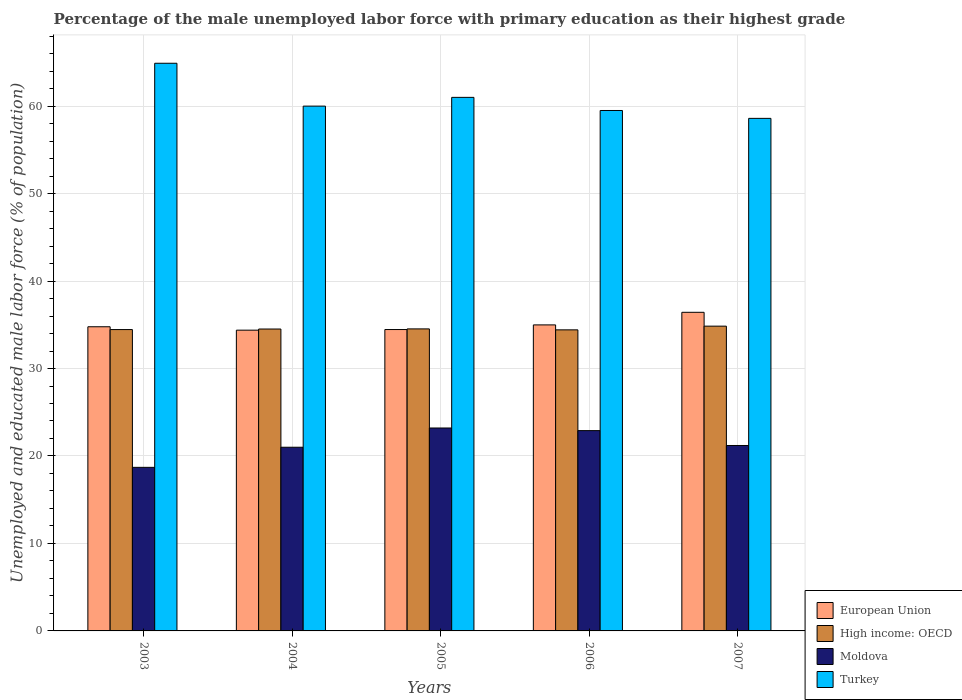How many different coloured bars are there?
Make the answer very short. 4. Are the number of bars on each tick of the X-axis equal?
Your response must be concise. Yes. How many bars are there on the 3rd tick from the right?
Your response must be concise. 4. What is the percentage of the unemployed male labor force with primary education in High income: OECD in 2004?
Offer a terse response. 34.51. Across all years, what is the maximum percentage of the unemployed male labor force with primary education in Turkey?
Your answer should be compact. 64.9. Across all years, what is the minimum percentage of the unemployed male labor force with primary education in European Union?
Provide a short and direct response. 34.39. In which year was the percentage of the unemployed male labor force with primary education in Moldova maximum?
Your response must be concise. 2005. In which year was the percentage of the unemployed male labor force with primary education in European Union minimum?
Your answer should be compact. 2004. What is the total percentage of the unemployed male labor force with primary education in Moldova in the graph?
Provide a succinct answer. 107. What is the difference between the percentage of the unemployed male labor force with primary education in Moldova in 2003 and that in 2006?
Make the answer very short. -4.2. What is the difference between the percentage of the unemployed male labor force with primary education in Moldova in 2003 and the percentage of the unemployed male labor force with primary education in High income: OECD in 2004?
Keep it short and to the point. -15.81. What is the average percentage of the unemployed male labor force with primary education in Moldova per year?
Keep it short and to the point. 21.4. In the year 2004, what is the difference between the percentage of the unemployed male labor force with primary education in European Union and percentage of the unemployed male labor force with primary education in High income: OECD?
Keep it short and to the point. -0.13. What is the ratio of the percentage of the unemployed male labor force with primary education in Turkey in 2003 to that in 2005?
Your answer should be compact. 1.06. Is the percentage of the unemployed male labor force with primary education in European Union in 2005 less than that in 2007?
Ensure brevity in your answer.  Yes. What is the difference between the highest and the second highest percentage of the unemployed male labor force with primary education in High income: OECD?
Ensure brevity in your answer.  0.31. What does the 1st bar from the left in 2004 represents?
Provide a succinct answer. European Union. What does the 4th bar from the right in 2004 represents?
Keep it short and to the point. European Union. How many bars are there?
Provide a succinct answer. 20. Are the values on the major ticks of Y-axis written in scientific E-notation?
Ensure brevity in your answer.  No. Does the graph contain grids?
Provide a succinct answer. Yes. How are the legend labels stacked?
Keep it short and to the point. Vertical. What is the title of the graph?
Ensure brevity in your answer.  Percentage of the male unemployed labor force with primary education as their highest grade. What is the label or title of the X-axis?
Your answer should be very brief. Years. What is the label or title of the Y-axis?
Your response must be concise. Unemployed and educated male labor force (% of population). What is the Unemployed and educated male labor force (% of population) of European Union in 2003?
Your response must be concise. 34.77. What is the Unemployed and educated male labor force (% of population) in High income: OECD in 2003?
Your response must be concise. 34.45. What is the Unemployed and educated male labor force (% of population) of Moldova in 2003?
Offer a terse response. 18.7. What is the Unemployed and educated male labor force (% of population) in Turkey in 2003?
Provide a succinct answer. 64.9. What is the Unemployed and educated male labor force (% of population) of European Union in 2004?
Make the answer very short. 34.39. What is the Unemployed and educated male labor force (% of population) of High income: OECD in 2004?
Give a very brief answer. 34.51. What is the Unemployed and educated male labor force (% of population) in Moldova in 2004?
Keep it short and to the point. 21. What is the Unemployed and educated male labor force (% of population) in Turkey in 2004?
Keep it short and to the point. 60. What is the Unemployed and educated male labor force (% of population) in European Union in 2005?
Your answer should be compact. 34.46. What is the Unemployed and educated male labor force (% of population) of High income: OECD in 2005?
Offer a terse response. 34.53. What is the Unemployed and educated male labor force (% of population) in Moldova in 2005?
Make the answer very short. 23.2. What is the Unemployed and educated male labor force (% of population) in European Union in 2006?
Provide a succinct answer. 34.99. What is the Unemployed and educated male labor force (% of population) of High income: OECD in 2006?
Give a very brief answer. 34.42. What is the Unemployed and educated male labor force (% of population) of Moldova in 2006?
Your answer should be compact. 22.9. What is the Unemployed and educated male labor force (% of population) of Turkey in 2006?
Make the answer very short. 59.5. What is the Unemployed and educated male labor force (% of population) of European Union in 2007?
Provide a short and direct response. 36.43. What is the Unemployed and educated male labor force (% of population) of High income: OECD in 2007?
Keep it short and to the point. 34.84. What is the Unemployed and educated male labor force (% of population) in Moldova in 2007?
Offer a very short reply. 21.2. What is the Unemployed and educated male labor force (% of population) in Turkey in 2007?
Make the answer very short. 58.6. Across all years, what is the maximum Unemployed and educated male labor force (% of population) in European Union?
Keep it short and to the point. 36.43. Across all years, what is the maximum Unemployed and educated male labor force (% of population) in High income: OECD?
Offer a terse response. 34.84. Across all years, what is the maximum Unemployed and educated male labor force (% of population) in Moldova?
Provide a succinct answer. 23.2. Across all years, what is the maximum Unemployed and educated male labor force (% of population) in Turkey?
Keep it short and to the point. 64.9. Across all years, what is the minimum Unemployed and educated male labor force (% of population) in European Union?
Give a very brief answer. 34.39. Across all years, what is the minimum Unemployed and educated male labor force (% of population) of High income: OECD?
Offer a terse response. 34.42. Across all years, what is the minimum Unemployed and educated male labor force (% of population) of Moldova?
Give a very brief answer. 18.7. Across all years, what is the minimum Unemployed and educated male labor force (% of population) in Turkey?
Give a very brief answer. 58.6. What is the total Unemployed and educated male labor force (% of population) of European Union in the graph?
Give a very brief answer. 175.03. What is the total Unemployed and educated male labor force (% of population) in High income: OECD in the graph?
Give a very brief answer. 172.76. What is the total Unemployed and educated male labor force (% of population) of Moldova in the graph?
Give a very brief answer. 107. What is the total Unemployed and educated male labor force (% of population) of Turkey in the graph?
Make the answer very short. 304. What is the difference between the Unemployed and educated male labor force (% of population) of European Union in 2003 and that in 2004?
Provide a succinct answer. 0.39. What is the difference between the Unemployed and educated male labor force (% of population) of High income: OECD in 2003 and that in 2004?
Your answer should be compact. -0.06. What is the difference between the Unemployed and educated male labor force (% of population) of Moldova in 2003 and that in 2004?
Make the answer very short. -2.3. What is the difference between the Unemployed and educated male labor force (% of population) of Turkey in 2003 and that in 2004?
Your answer should be very brief. 4.9. What is the difference between the Unemployed and educated male labor force (% of population) in European Union in 2003 and that in 2005?
Your answer should be compact. 0.32. What is the difference between the Unemployed and educated male labor force (% of population) in High income: OECD in 2003 and that in 2005?
Keep it short and to the point. -0.08. What is the difference between the Unemployed and educated male labor force (% of population) in Turkey in 2003 and that in 2005?
Make the answer very short. 3.9. What is the difference between the Unemployed and educated male labor force (% of population) of European Union in 2003 and that in 2006?
Keep it short and to the point. -0.21. What is the difference between the Unemployed and educated male labor force (% of population) in High income: OECD in 2003 and that in 2006?
Give a very brief answer. 0.03. What is the difference between the Unemployed and educated male labor force (% of population) in European Union in 2003 and that in 2007?
Make the answer very short. -1.65. What is the difference between the Unemployed and educated male labor force (% of population) in High income: OECD in 2003 and that in 2007?
Provide a short and direct response. -0.39. What is the difference between the Unemployed and educated male labor force (% of population) of European Union in 2004 and that in 2005?
Give a very brief answer. -0.07. What is the difference between the Unemployed and educated male labor force (% of population) in High income: OECD in 2004 and that in 2005?
Provide a short and direct response. -0.02. What is the difference between the Unemployed and educated male labor force (% of population) in European Union in 2004 and that in 2006?
Make the answer very short. -0.6. What is the difference between the Unemployed and educated male labor force (% of population) of High income: OECD in 2004 and that in 2006?
Offer a terse response. 0.09. What is the difference between the Unemployed and educated male labor force (% of population) of Moldova in 2004 and that in 2006?
Make the answer very short. -1.9. What is the difference between the Unemployed and educated male labor force (% of population) in Turkey in 2004 and that in 2006?
Offer a terse response. 0.5. What is the difference between the Unemployed and educated male labor force (% of population) of European Union in 2004 and that in 2007?
Your answer should be compact. -2.04. What is the difference between the Unemployed and educated male labor force (% of population) in High income: OECD in 2004 and that in 2007?
Ensure brevity in your answer.  -0.33. What is the difference between the Unemployed and educated male labor force (% of population) in Turkey in 2004 and that in 2007?
Give a very brief answer. 1.4. What is the difference between the Unemployed and educated male labor force (% of population) of European Union in 2005 and that in 2006?
Ensure brevity in your answer.  -0.53. What is the difference between the Unemployed and educated male labor force (% of population) of High income: OECD in 2005 and that in 2006?
Give a very brief answer. 0.11. What is the difference between the Unemployed and educated male labor force (% of population) in Moldova in 2005 and that in 2006?
Make the answer very short. 0.3. What is the difference between the Unemployed and educated male labor force (% of population) of European Union in 2005 and that in 2007?
Give a very brief answer. -1.97. What is the difference between the Unemployed and educated male labor force (% of population) in High income: OECD in 2005 and that in 2007?
Give a very brief answer. -0.31. What is the difference between the Unemployed and educated male labor force (% of population) in Moldova in 2005 and that in 2007?
Offer a very short reply. 2. What is the difference between the Unemployed and educated male labor force (% of population) of Turkey in 2005 and that in 2007?
Your answer should be very brief. 2.4. What is the difference between the Unemployed and educated male labor force (% of population) of European Union in 2006 and that in 2007?
Offer a very short reply. -1.44. What is the difference between the Unemployed and educated male labor force (% of population) of High income: OECD in 2006 and that in 2007?
Provide a short and direct response. -0.42. What is the difference between the Unemployed and educated male labor force (% of population) in European Union in 2003 and the Unemployed and educated male labor force (% of population) in High income: OECD in 2004?
Ensure brevity in your answer.  0.26. What is the difference between the Unemployed and educated male labor force (% of population) of European Union in 2003 and the Unemployed and educated male labor force (% of population) of Moldova in 2004?
Your answer should be compact. 13.77. What is the difference between the Unemployed and educated male labor force (% of population) of European Union in 2003 and the Unemployed and educated male labor force (% of population) of Turkey in 2004?
Offer a very short reply. -25.23. What is the difference between the Unemployed and educated male labor force (% of population) of High income: OECD in 2003 and the Unemployed and educated male labor force (% of population) of Moldova in 2004?
Ensure brevity in your answer.  13.45. What is the difference between the Unemployed and educated male labor force (% of population) in High income: OECD in 2003 and the Unemployed and educated male labor force (% of population) in Turkey in 2004?
Offer a terse response. -25.55. What is the difference between the Unemployed and educated male labor force (% of population) of Moldova in 2003 and the Unemployed and educated male labor force (% of population) of Turkey in 2004?
Your response must be concise. -41.3. What is the difference between the Unemployed and educated male labor force (% of population) in European Union in 2003 and the Unemployed and educated male labor force (% of population) in High income: OECD in 2005?
Your answer should be compact. 0.24. What is the difference between the Unemployed and educated male labor force (% of population) of European Union in 2003 and the Unemployed and educated male labor force (% of population) of Moldova in 2005?
Your answer should be compact. 11.57. What is the difference between the Unemployed and educated male labor force (% of population) in European Union in 2003 and the Unemployed and educated male labor force (% of population) in Turkey in 2005?
Provide a short and direct response. -26.23. What is the difference between the Unemployed and educated male labor force (% of population) in High income: OECD in 2003 and the Unemployed and educated male labor force (% of population) in Moldova in 2005?
Provide a short and direct response. 11.25. What is the difference between the Unemployed and educated male labor force (% of population) in High income: OECD in 2003 and the Unemployed and educated male labor force (% of population) in Turkey in 2005?
Your answer should be very brief. -26.55. What is the difference between the Unemployed and educated male labor force (% of population) of Moldova in 2003 and the Unemployed and educated male labor force (% of population) of Turkey in 2005?
Offer a very short reply. -42.3. What is the difference between the Unemployed and educated male labor force (% of population) of European Union in 2003 and the Unemployed and educated male labor force (% of population) of High income: OECD in 2006?
Give a very brief answer. 0.35. What is the difference between the Unemployed and educated male labor force (% of population) of European Union in 2003 and the Unemployed and educated male labor force (% of population) of Moldova in 2006?
Ensure brevity in your answer.  11.87. What is the difference between the Unemployed and educated male labor force (% of population) of European Union in 2003 and the Unemployed and educated male labor force (% of population) of Turkey in 2006?
Make the answer very short. -24.73. What is the difference between the Unemployed and educated male labor force (% of population) in High income: OECD in 2003 and the Unemployed and educated male labor force (% of population) in Moldova in 2006?
Keep it short and to the point. 11.55. What is the difference between the Unemployed and educated male labor force (% of population) of High income: OECD in 2003 and the Unemployed and educated male labor force (% of population) of Turkey in 2006?
Keep it short and to the point. -25.05. What is the difference between the Unemployed and educated male labor force (% of population) in Moldova in 2003 and the Unemployed and educated male labor force (% of population) in Turkey in 2006?
Your response must be concise. -40.8. What is the difference between the Unemployed and educated male labor force (% of population) in European Union in 2003 and the Unemployed and educated male labor force (% of population) in High income: OECD in 2007?
Keep it short and to the point. -0.07. What is the difference between the Unemployed and educated male labor force (% of population) in European Union in 2003 and the Unemployed and educated male labor force (% of population) in Moldova in 2007?
Make the answer very short. 13.57. What is the difference between the Unemployed and educated male labor force (% of population) in European Union in 2003 and the Unemployed and educated male labor force (% of population) in Turkey in 2007?
Provide a short and direct response. -23.83. What is the difference between the Unemployed and educated male labor force (% of population) in High income: OECD in 2003 and the Unemployed and educated male labor force (% of population) in Moldova in 2007?
Ensure brevity in your answer.  13.25. What is the difference between the Unemployed and educated male labor force (% of population) of High income: OECD in 2003 and the Unemployed and educated male labor force (% of population) of Turkey in 2007?
Offer a very short reply. -24.15. What is the difference between the Unemployed and educated male labor force (% of population) of Moldova in 2003 and the Unemployed and educated male labor force (% of population) of Turkey in 2007?
Offer a terse response. -39.9. What is the difference between the Unemployed and educated male labor force (% of population) in European Union in 2004 and the Unemployed and educated male labor force (% of population) in High income: OECD in 2005?
Keep it short and to the point. -0.14. What is the difference between the Unemployed and educated male labor force (% of population) of European Union in 2004 and the Unemployed and educated male labor force (% of population) of Moldova in 2005?
Your answer should be very brief. 11.19. What is the difference between the Unemployed and educated male labor force (% of population) in European Union in 2004 and the Unemployed and educated male labor force (% of population) in Turkey in 2005?
Provide a short and direct response. -26.61. What is the difference between the Unemployed and educated male labor force (% of population) in High income: OECD in 2004 and the Unemployed and educated male labor force (% of population) in Moldova in 2005?
Offer a very short reply. 11.31. What is the difference between the Unemployed and educated male labor force (% of population) of High income: OECD in 2004 and the Unemployed and educated male labor force (% of population) of Turkey in 2005?
Your answer should be very brief. -26.49. What is the difference between the Unemployed and educated male labor force (% of population) in Moldova in 2004 and the Unemployed and educated male labor force (% of population) in Turkey in 2005?
Ensure brevity in your answer.  -40. What is the difference between the Unemployed and educated male labor force (% of population) in European Union in 2004 and the Unemployed and educated male labor force (% of population) in High income: OECD in 2006?
Your response must be concise. -0.03. What is the difference between the Unemployed and educated male labor force (% of population) in European Union in 2004 and the Unemployed and educated male labor force (% of population) in Moldova in 2006?
Give a very brief answer. 11.49. What is the difference between the Unemployed and educated male labor force (% of population) in European Union in 2004 and the Unemployed and educated male labor force (% of population) in Turkey in 2006?
Ensure brevity in your answer.  -25.11. What is the difference between the Unemployed and educated male labor force (% of population) of High income: OECD in 2004 and the Unemployed and educated male labor force (% of population) of Moldova in 2006?
Your answer should be very brief. 11.61. What is the difference between the Unemployed and educated male labor force (% of population) of High income: OECD in 2004 and the Unemployed and educated male labor force (% of population) of Turkey in 2006?
Offer a very short reply. -24.99. What is the difference between the Unemployed and educated male labor force (% of population) in Moldova in 2004 and the Unemployed and educated male labor force (% of population) in Turkey in 2006?
Provide a short and direct response. -38.5. What is the difference between the Unemployed and educated male labor force (% of population) in European Union in 2004 and the Unemployed and educated male labor force (% of population) in High income: OECD in 2007?
Your response must be concise. -0.46. What is the difference between the Unemployed and educated male labor force (% of population) in European Union in 2004 and the Unemployed and educated male labor force (% of population) in Moldova in 2007?
Give a very brief answer. 13.19. What is the difference between the Unemployed and educated male labor force (% of population) in European Union in 2004 and the Unemployed and educated male labor force (% of population) in Turkey in 2007?
Offer a very short reply. -24.21. What is the difference between the Unemployed and educated male labor force (% of population) in High income: OECD in 2004 and the Unemployed and educated male labor force (% of population) in Moldova in 2007?
Your answer should be compact. 13.31. What is the difference between the Unemployed and educated male labor force (% of population) in High income: OECD in 2004 and the Unemployed and educated male labor force (% of population) in Turkey in 2007?
Your response must be concise. -24.09. What is the difference between the Unemployed and educated male labor force (% of population) in Moldova in 2004 and the Unemployed and educated male labor force (% of population) in Turkey in 2007?
Your answer should be compact. -37.6. What is the difference between the Unemployed and educated male labor force (% of population) in European Union in 2005 and the Unemployed and educated male labor force (% of population) in High income: OECD in 2006?
Make the answer very short. 0.04. What is the difference between the Unemployed and educated male labor force (% of population) of European Union in 2005 and the Unemployed and educated male labor force (% of population) of Moldova in 2006?
Make the answer very short. 11.56. What is the difference between the Unemployed and educated male labor force (% of population) of European Union in 2005 and the Unemployed and educated male labor force (% of population) of Turkey in 2006?
Your answer should be very brief. -25.04. What is the difference between the Unemployed and educated male labor force (% of population) in High income: OECD in 2005 and the Unemployed and educated male labor force (% of population) in Moldova in 2006?
Give a very brief answer. 11.63. What is the difference between the Unemployed and educated male labor force (% of population) of High income: OECD in 2005 and the Unemployed and educated male labor force (% of population) of Turkey in 2006?
Keep it short and to the point. -24.97. What is the difference between the Unemployed and educated male labor force (% of population) of Moldova in 2005 and the Unemployed and educated male labor force (% of population) of Turkey in 2006?
Give a very brief answer. -36.3. What is the difference between the Unemployed and educated male labor force (% of population) of European Union in 2005 and the Unemployed and educated male labor force (% of population) of High income: OECD in 2007?
Your response must be concise. -0.39. What is the difference between the Unemployed and educated male labor force (% of population) of European Union in 2005 and the Unemployed and educated male labor force (% of population) of Moldova in 2007?
Give a very brief answer. 13.26. What is the difference between the Unemployed and educated male labor force (% of population) of European Union in 2005 and the Unemployed and educated male labor force (% of population) of Turkey in 2007?
Offer a very short reply. -24.14. What is the difference between the Unemployed and educated male labor force (% of population) of High income: OECD in 2005 and the Unemployed and educated male labor force (% of population) of Moldova in 2007?
Your answer should be compact. 13.33. What is the difference between the Unemployed and educated male labor force (% of population) of High income: OECD in 2005 and the Unemployed and educated male labor force (% of population) of Turkey in 2007?
Give a very brief answer. -24.07. What is the difference between the Unemployed and educated male labor force (% of population) in Moldova in 2005 and the Unemployed and educated male labor force (% of population) in Turkey in 2007?
Make the answer very short. -35.4. What is the difference between the Unemployed and educated male labor force (% of population) of European Union in 2006 and the Unemployed and educated male labor force (% of population) of High income: OECD in 2007?
Make the answer very short. 0.14. What is the difference between the Unemployed and educated male labor force (% of population) of European Union in 2006 and the Unemployed and educated male labor force (% of population) of Moldova in 2007?
Offer a terse response. 13.79. What is the difference between the Unemployed and educated male labor force (% of population) in European Union in 2006 and the Unemployed and educated male labor force (% of population) in Turkey in 2007?
Offer a very short reply. -23.61. What is the difference between the Unemployed and educated male labor force (% of population) of High income: OECD in 2006 and the Unemployed and educated male labor force (% of population) of Moldova in 2007?
Offer a very short reply. 13.22. What is the difference between the Unemployed and educated male labor force (% of population) of High income: OECD in 2006 and the Unemployed and educated male labor force (% of population) of Turkey in 2007?
Keep it short and to the point. -24.18. What is the difference between the Unemployed and educated male labor force (% of population) of Moldova in 2006 and the Unemployed and educated male labor force (% of population) of Turkey in 2007?
Your response must be concise. -35.7. What is the average Unemployed and educated male labor force (% of population) of European Union per year?
Give a very brief answer. 35.01. What is the average Unemployed and educated male labor force (% of population) in High income: OECD per year?
Offer a very short reply. 34.55. What is the average Unemployed and educated male labor force (% of population) in Moldova per year?
Ensure brevity in your answer.  21.4. What is the average Unemployed and educated male labor force (% of population) in Turkey per year?
Your answer should be very brief. 60.8. In the year 2003, what is the difference between the Unemployed and educated male labor force (% of population) in European Union and Unemployed and educated male labor force (% of population) in High income: OECD?
Give a very brief answer. 0.32. In the year 2003, what is the difference between the Unemployed and educated male labor force (% of population) of European Union and Unemployed and educated male labor force (% of population) of Moldova?
Your answer should be very brief. 16.07. In the year 2003, what is the difference between the Unemployed and educated male labor force (% of population) in European Union and Unemployed and educated male labor force (% of population) in Turkey?
Your answer should be very brief. -30.13. In the year 2003, what is the difference between the Unemployed and educated male labor force (% of population) in High income: OECD and Unemployed and educated male labor force (% of population) in Moldova?
Keep it short and to the point. 15.75. In the year 2003, what is the difference between the Unemployed and educated male labor force (% of population) in High income: OECD and Unemployed and educated male labor force (% of population) in Turkey?
Your response must be concise. -30.45. In the year 2003, what is the difference between the Unemployed and educated male labor force (% of population) of Moldova and Unemployed and educated male labor force (% of population) of Turkey?
Give a very brief answer. -46.2. In the year 2004, what is the difference between the Unemployed and educated male labor force (% of population) of European Union and Unemployed and educated male labor force (% of population) of High income: OECD?
Ensure brevity in your answer.  -0.13. In the year 2004, what is the difference between the Unemployed and educated male labor force (% of population) in European Union and Unemployed and educated male labor force (% of population) in Moldova?
Your answer should be very brief. 13.39. In the year 2004, what is the difference between the Unemployed and educated male labor force (% of population) in European Union and Unemployed and educated male labor force (% of population) in Turkey?
Make the answer very short. -25.61. In the year 2004, what is the difference between the Unemployed and educated male labor force (% of population) of High income: OECD and Unemployed and educated male labor force (% of population) of Moldova?
Give a very brief answer. 13.51. In the year 2004, what is the difference between the Unemployed and educated male labor force (% of population) of High income: OECD and Unemployed and educated male labor force (% of population) of Turkey?
Provide a short and direct response. -25.49. In the year 2004, what is the difference between the Unemployed and educated male labor force (% of population) of Moldova and Unemployed and educated male labor force (% of population) of Turkey?
Make the answer very short. -39. In the year 2005, what is the difference between the Unemployed and educated male labor force (% of population) of European Union and Unemployed and educated male labor force (% of population) of High income: OECD?
Offer a very short reply. -0.07. In the year 2005, what is the difference between the Unemployed and educated male labor force (% of population) in European Union and Unemployed and educated male labor force (% of population) in Moldova?
Give a very brief answer. 11.26. In the year 2005, what is the difference between the Unemployed and educated male labor force (% of population) in European Union and Unemployed and educated male labor force (% of population) in Turkey?
Give a very brief answer. -26.54. In the year 2005, what is the difference between the Unemployed and educated male labor force (% of population) in High income: OECD and Unemployed and educated male labor force (% of population) in Moldova?
Your response must be concise. 11.33. In the year 2005, what is the difference between the Unemployed and educated male labor force (% of population) of High income: OECD and Unemployed and educated male labor force (% of population) of Turkey?
Offer a terse response. -26.47. In the year 2005, what is the difference between the Unemployed and educated male labor force (% of population) of Moldova and Unemployed and educated male labor force (% of population) of Turkey?
Keep it short and to the point. -37.8. In the year 2006, what is the difference between the Unemployed and educated male labor force (% of population) in European Union and Unemployed and educated male labor force (% of population) in High income: OECD?
Offer a terse response. 0.57. In the year 2006, what is the difference between the Unemployed and educated male labor force (% of population) of European Union and Unemployed and educated male labor force (% of population) of Moldova?
Make the answer very short. 12.09. In the year 2006, what is the difference between the Unemployed and educated male labor force (% of population) of European Union and Unemployed and educated male labor force (% of population) of Turkey?
Keep it short and to the point. -24.51. In the year 2006, what is the difference between the Unemployed and educated male labor force (% of population) in High income: OECD and Unemployed and educated male labor force (% of population) in Moldova?
Keep it short and to the point. 11.52. In the year 2006, what is the difference between the Unemployed and educated male labor force (% of population) in High income: OECD and Unemployed and educated male labor force (% of population) in Turkey?
Offer a terse response. -25.08. In the year 2006, what is the difference between the Unemployed and educated male labor force (% of population) of Moldova and Unemployed and educated male labor force (% of population) of Turkey?
Your response must be concise. -36.6. In the year 2007, what is the difference between the Unemployed and educated male labor force (% of population) in European Union and Unemployed and educated male labor force (% of population) in High income: OECD?
Keep it short and to the point. 1.58. In the year 2007, what is the difference between the Unemployed and educated male labor force (% of population) of European Union and Unemployed and educated male labor force (% of population) of Moldova?
Provide a succinct answer. 15.23. In the year 2007, what is the difference between the Unemployed and educated male labor force (% of population) in European Union and Unemployed and educated male labor force (% of population) in Turkey?
Provide a succinct answer. -22.17. In the year 2007, what is the difference between the Unemployed and educated male labor force (% of population) of High income: OECD and Unemployed and educated male labor force (% of population) of Moldova?
Your response must be concise. 13.64. In the year 2007, what is the difference between the Unemployed and educated male labor force (% of population) in High income: OECD and Unemployed and educated male labor force (% of population) in Turkey?
Your response must be concise. -23.75. In the year 2007, what is the difference between the Unemployed and educated male labor force (% of population) of Moldova and Unemployed and educated male labor force (% of population) of Turkey?
Your answer should be compact. -37.4. What is the ratio of the Unemployed and educated male labor force (% of population) in European Union in 2003 to that in 2004?
Offer a very short reply. 1.01. What is the ratio of the Unemployed and educated male labor force (% of population) in High income: OECD in 2003 to that in 2004?
Ensure brevity in your answer.  1. What is the ratio of the Unemployed and educated male labor force (% of population) in Moldova in 2003 to that in 2004?
Keep it short and to the point. 0.89. What is the ratio of the Unemployed and educated male labor force (% of population) of Turkey in 2003 to that in 2004?
Ensure brevity in your answer.  1.08. What is the ratio of the Unemployed and educated male labor force (% of population) of European Union in 2003 to that in 2005?
Your answer should be very brief. 1.01. What is the ratio of the Unemployed and educated male labor force (% of population) of Moldova in 2003 to that in 2005?
Offer a very short reply. 0.81. What is the ratio of the Unemployed and educated male labor force (% of population) in Turkey in 2003 to that in 2005?
Keep it short and to the point. 1.06. What is the ratio of the Unemployed and educated male labor force (% of population) in High income: OECD in 2003 to that in 2006?
Your answer should be very brief. 1. What is the ratio of the Unemployed and educated male labor force (% of population) in Moldova in 2003 to that in 2006?
Offer a very short reply. 0.82. What is the ratio of the Unemployed and educated male labor force (% of population) in Turkey in 2003 to that in 2006?
Keep it short and to the point. 1.09. What is the ratio of the Unemployed and educated male labor force (% of population) in European Union in 2003 to that in 2007?
Ensure brevity in your answer.  0.95. What is the ratio of the Unemployed and educated male labor force (% of population) in High income: OECD in 2003 to that in 2007?
Your answer should be compact. 0.99. What is the ratio of the Unemployed and educated male labor force (% of population) in Moldova in 2003 to that in 2007?
Give a very brief answer. 0.88. What is the ratio of the Unemployed and educated male labor force (% of population) of Turkey in 2003 to that in 2007?
Provide a succinct answer. 1.11. What is the ratio of the Unemployed and educated male labor force (% of population) in Moldova in 2004 to that in 2005?
Provide a succinct answer. 0.91. What is the ratio of the Unemployed and educated male labor force (% of population) in Turkey in 2004 to that in 2005?
Provide a succinct answer. 0.98. What is the ratio of the Unemployed and educated male labor force (% of population) in European Union in 2004 to that in 2006?
Your answer should be compact. 0.98. What is the ratio of the Unemployed and educated male labor force (% of population) in High income: OECD in 2004 to that in 2006?
Your answer should be very brief. 1. What is the ratio of the Unemployed and educated male labor force (% of population) of Moldova in 2004 to that in 2006?
Provide a short and direct response. 0.92. What is the ratio of the Unemployed and educated male labor force (% of population) in Turkey in 2004 to that in 2006?
Keep it short and to the point. 1.01. What is the ratio of the Unemployed and educated male labor force (% of population) of European Union in 2004 to that in 2007?
Your answer should be compact. 0.94. What is the ratio of the Unemployed and educated male labor force (% of population) in High income: OECD in 2004 to that in 2007?
Make the answer very short. 0.99. What is the ratio of the Unemployed and educated male labor force (% of population) of Moldova in 2004 to that in 2007?
Provide a succinct answer. 0.99. What is the ratio of the Unemployed and educated male labor force (% of population) in Turkey in 2004 to that in 2007?
Provide a short and direct response. 1.02. What is the ratio of the Unemployed and educated male labor force (% of population) of European Union in 2005 to that in 2006?
Make the answer very short. 0.98. What is the ratio of the Unemployed and educated male labor force (% of population) in Moldova in 2005 to that in 2006?
Offer a terse response. 1.01. What is the ratio of the Unemployed and educated male labor force (% of population) in Turkey in 2005 to that in 2006?
Offer a very short reply. 1.03. What is the ratio of the Unemployed and educated male labor force (% of population) of European Union in 2005 to that in 2007?
Give a very brief answer. 0.95. What is the ratio of the Unemployed and educated male labor force (% of population) in Moldova in 2005 to that in 2007?
Your answer should be very brief. 1.09. What is the ratio of the Unemployed and educated male labor force (% of population) of Turkey in 2005 to that in 2007?
Your answer should be very brief. 1.04. What is the ratio of the Unemployed and educated male labor force (% of population) of European Union in 2006 to that in 2007?
Provide a succinct answer. 0.96. What is the ratio of the Unemployed and educated male labor force (% of population) of High income: OECD in 2006 to that in 2007?
Make the answer very short. 0.99. What is the ratio of the Unemployed and educated male labor force (% of population) of Moldova in 2006 to that in 2007?
Your answer should be compact. 1.08. What is the ratio of the Unemployed and educated male labor force (% of population) of Turkey in 2006 to that in 2007?
Offer a very short reply. 1.02. What is the difference between the highest and the second highest Unemployed and educated male labor force (% of population) in European Union?
Keep it short and to the point. 1.44. What is the difference between the highest and the second highest Unemployed and educated male labor force (% of population) in High income: OECD?
Offer a very short reply. 0.31. What is the difference between the highest and the second highest Unemployed and educated male labor force (% of population) of Moldova?
Your answer should be very brief. 0.3. What is the difference between the highest and the lowest Unemployed and educated male labor force (% of population) in European Union?
Ensure brevity in your answer.  2.04. What is the difference between the highest and the lowest Unemployed and educated male labor force (% of population) of High income: OECD?
Your response must be concise. 0.42. What is the difference between the highest and the lowest Unemployed and educated male labor force (% of population) of Turkey?
Ensure brevity in your answer.  6.3. 